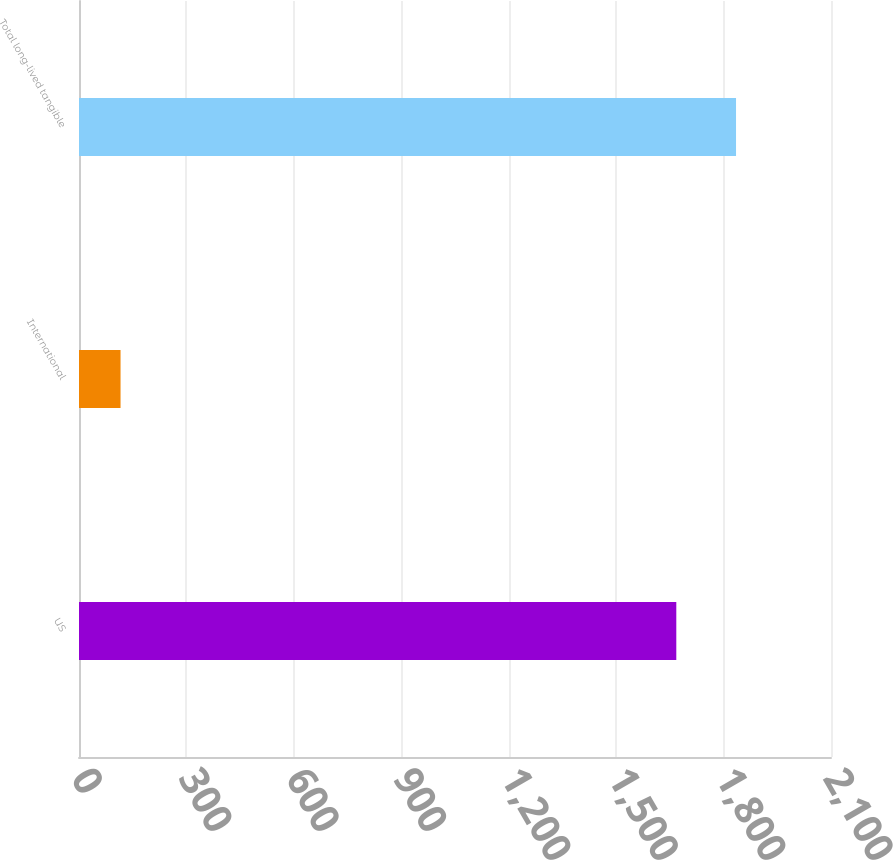<chart> <loc_0><loc_0><loc_500><loc_500><bar_chart><fcel>US<fcel>International<fcel>Total long-lived tangible<nl><fcel>1668<fcel>116<fcel>1834.8<nl></chart> 